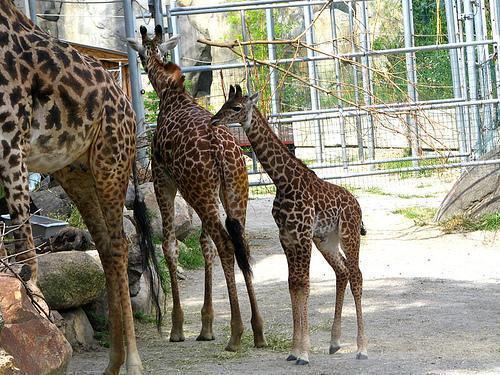How many heads are in the photo?
Give a very brief answer. 2. How many legs are visible in the photo?
Give a very brief answer. 11. How many of the giraffes are babies?
Give a very brief answer. 1. How many animals are shown?
Give a very brief answer. 3. How many animals are seen in the image?
Give a very brief answer. 3. How many of the animals eyes can be seen?
Give a very brief answer. 1. How many young giraffe are visible in this photo?
Give a very brief answer. 1. How many giraffe heads are visibly looking away from the camera?
Give a very brief answer. 1. How many giraffes are visible?
Give a very brief answer. 3. How many young giraffes are visible?
Give a very brief answer. 2. 